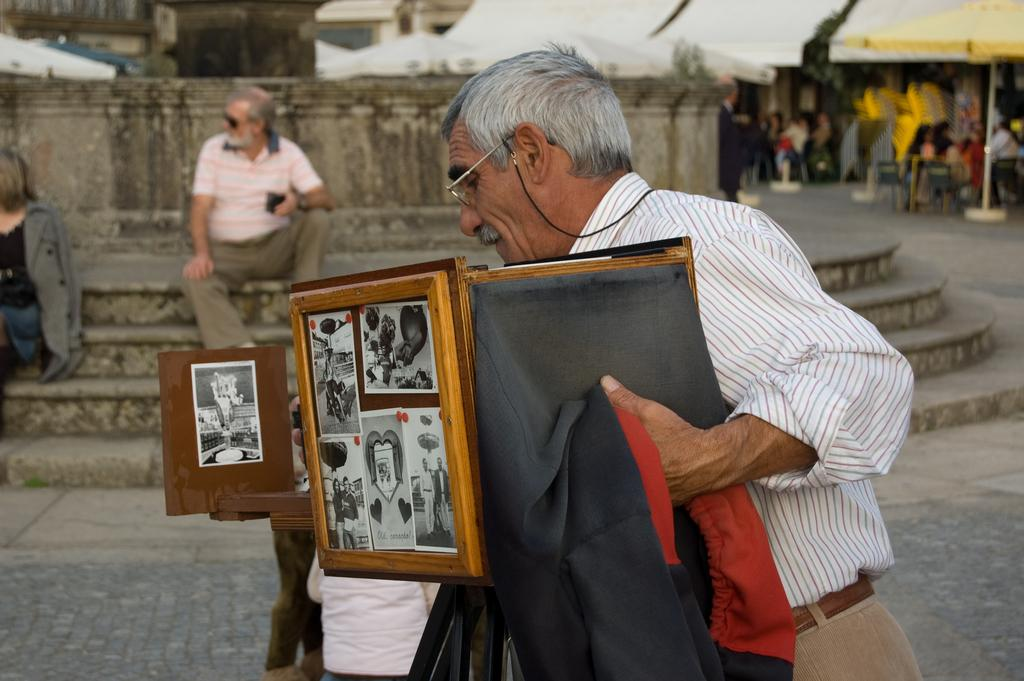What is the man in the image doing? The man is standing in the image and holding a camera. How is the camera positioned in the image? The camera is on a tripod stand. What can be seen in the background of the image? There is a group of people, chairs, and canopy tents in the background of the image. What type of patch is being discovered by the tank in the image? There is no tank or patch present in the image. 